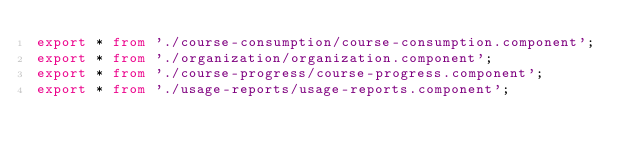Convert code to text. <code><loc_0><loc_0><loc_500><loc_500><_TypeScript_>export * from './course-consumption/course-consumption.component';
export * from './organization/organization.component';
export * from './course-progress/course-progress.component';
export * from './usage-reports/usage-reports.component';
</code> 